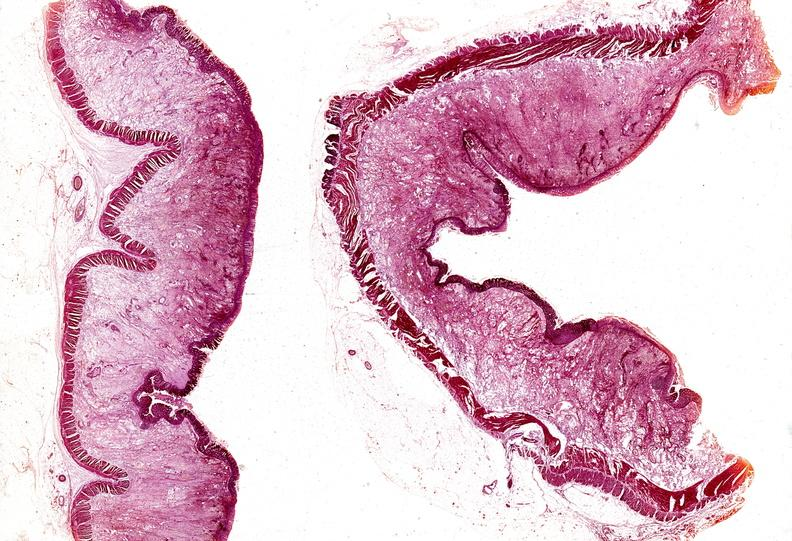where is this from?
Answer the question using a single word or phrase. Gastrointestinal system 